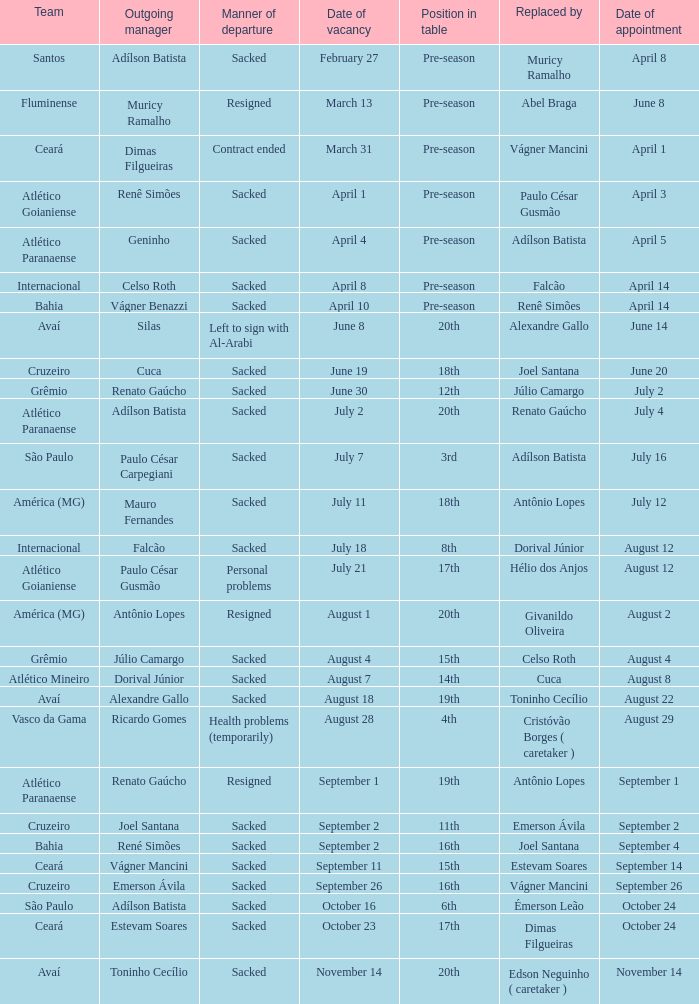How many times did Silas leave as a team manager? 1.0. 